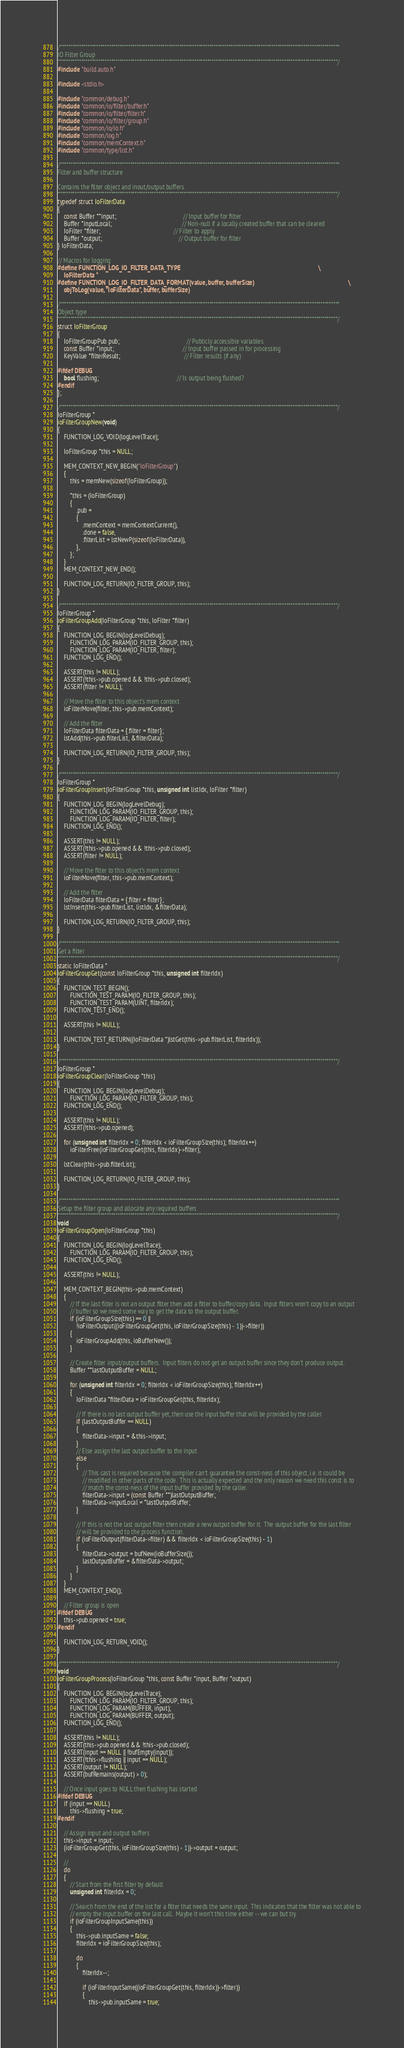Convert code to text. <code><loc_0><loc_0><loc_500><loc_500><_C_>/***********************************************************************************************************************************
IO Filter Group
***********************************************************************************************************************************/
#include "build.auto.h"

#include <stdio.h>

#include "common/debug.h"
#include "common/io/filter/buffer.h"
#include "common/io/filter/filter.h"
#include "common/io/filter/group.h"
#include "common/io/io.h"
#include "common/log.h"
#include "common/memContext.h"
#include "common/type/list.h"

/***********************************************************************************************************************************
Filter and buffer structure

Contains the filter object and inout/output buffers.
***********************************************************************************************************************************/
typedef struct IoFilterData
{
    const Buffer **input;                                           // Input buffer for filter
    Buffer *inputLocal;                                             // Non-null if a locally created buffer that can be cleared
    IoFilter *filter;                                               // Filter to apply
    Buffer *output;                                                 // Output buffer for filter
} IoFilterData;

// Macros for logging
#define FUNCTION_LOG_IO_FILTER_DATA_TYPE                                                                                           \
    IoFilterData *
#define FUNCTION_LOG_IO_FILTER_DATA_FORMAT(value, buffer, bufferSize)                                                              \
    objToLog(value, "IoFilterData", buffer, bufferSize)

/***********************************************************************************************************************************
Object type
***********************************************************************************************************************************/
struct IoFilterGroup
{
    IoFilterGroupPub pub;                                           // Publicly accessible variables
    const Buffer *input;                                            // Input buffer passed in for processing
    KeyValue *filterResult;                                         // Filter results (if any)

#ifdef DEBUG
    bool flushing;                                                  // Is output being flushed?
#endif
};

/**********************************************************************************************************************************/
IoFilterGroup *
ioFilterGroupNew(void)
{
    FUNCTION_LOG_VOID(logLevelTrace);

    IoFilterGroup *this = NULL;

    MEM_CONTEXT_NEW_BEGIN("IoFilterGroup")
    {
        this = memNew(sizeof(IoFilterGroup));

        *this = (IoFilterGroup)
        {
            .pub =
            {
                .memContext = memContextCurrent(),
                .done = false,
                .filterList = lstNewP(sizeof(IoFilterData)),
            },
        };
    }
    MEM_CONTEXT_NEW_END();

    FUNCTION_LOG_RETURN(IO_FILTER_GROUP, this);
}

/**********************************************************************************************************************************/
IoFilterGroup *
ioFilterGroupAdd(IoFilterGroup *this, IoFilter *filter)
{
    FUNCTION_LOG_BEGIN(logLevelDebug);
        FUNCTION_LOG_PARAM(IO_FILTER_GROUP, this);
        FUNCTION_LOG_PARAM(IO_FILTER, filter);
    FUNCTION_LOG_END();

    ASSERT(this != NULL);
    ASSERT(!this->pub.opened && !this->pub.closed);
    ASSERT(filter != NULL);

    // Move the filter to this object's mem context
    ioFilterMove(filter, this->pub.memContext);

    // Add the filter
    IoFilterData filterData = {.filter = filter};
    lstAdd(this->pub.filterList, &filterData);

    FUNCTION_LOG_RETURN(IO_FILTER_GROUP, this);
}

/**********************************************************************************************************************************/
IoFilterGroup *
ioFilterGroupInsert(IoFilterGroup *this, unsigned int listIdx, IoFilter *filter)
{
    FUNCTION_LOG_BEGIN(logLevelDebug);
        FUNCTION_LOG_PARAM(IO_FILTER_GROUP, this);
        FUNCTION_LOG_PARAM(IO_FILTER, filter);
    FUNCTION_LOG_END();

    ASSERT(this != NULL);
    ASSERT(!this->pub.opened && !this->pub.closed);
    ASSERT(filter != NULL);

    // Move the filter to this object's mem context
    ioFilterMove(filter, this->pub.memContext);

    // Add the filter
    IoFilterData filterData = {.filter = filter};
    lstInsert(this->pub.filterList, listIdx, &filterData);

    FUNCTION_LOG_RETURN(IO_FILTER_GROUP, this);
}

/***********************************************************************************************************************************
Get a filter
***********************************************************************************************************************************/
static IoFilterData *
ioFilterGroupGet(const IoFilterGroup *this, unsigned int filterIdx)
{
    FUNCTION_TEST_BEGIN();
        FUNCTION_TEST_PARAM(IO_FILTER_GROUP, this);
        FUNCTION_TEST_PARAM(UINT, filterIdx);
    FUNCTION_TEST_END();

    ASSERT(this != NULL);

    FUNCTION_TEST_RETURN((IoFilterData *)lstGet(this->pub.filterList, filterIdx));
}

/**********************************************************************************************************************************/
IoFilterGroup *
ioFilterGroupClear(IoFilterGroup *this)
{
    FUNCTION_LOG_BEGIN(logLevelDebug);
        FUNCTION_LOG_PARAM(IO_FILTER_GROUP, this);
    FUNCTION_LOG_END();

    ASSERT(this != NULL);
    ASSERT(!this->pub.opened);

    for (unsigned int filterIdx = 0; filterIdx < ioFilterGroupSize(this); filterIdx++)
        ioFilterFree(ioFilterGroupGet(this, filterIdx)->filter);

    lstClear(this->pub.filterList);

    FUNCTION_LOG_RETURN(IO_FILTER_GROUP, this);
}

/***********************************************************************************************************************************
Setup the filter group and allocate any required buffers
***********************************************************************************************************************************/
void
ioFilterGroupOpen(IoFilterGroup *this)
{
    FUNCTION_LOG_BEGIN(logLevelTrace);
        FUNCTION_LOG_PARAM(IO_FILTER_GROUP, this);
    FUNCTION_LOG_END();

    ASSERT(this != NULL);

    MEM_CONTEXT_BEGIN(this->pub.memContext)
    {
        // If the last filter is not an output filter then add a filter to buffer/copy data.  Input filters won't copy to an output
        // buffer so we need some way to get the data to the output buffer.
        if (ioFilterGroupSize(this) == 0 ||
            !ioFilterOutput((ioFilterGroupGet(this, ioFilterGroupSize(this) - 1))->filter))
        {
            ioFilterGroupAdd(this, ioBufferNew());
        }

        // Create filter input/output buffers.  Input filters do not get an output buffer since they don't produce output.
        Buffer **lastOutputBuffer = NULL;

        for (unsigned int filterIdx = 0; filterIdx < ioFilterGroupSize(this); filterIdx++)
        {
            IoFilterData *filterData = ioFilterGroupGet(this, filterIdx);

            // If there is no last output buffer yet, then use the input buffer that will be provided by the caller
            if (lastOutputBuffer == NULL)
            {
                filterData->input = &this->input;
            }
            // Else assign the last output buffer to the input
            else
            {
                // This cast is required because the compiler can't guarantee the const-ness of this object, i.e. it could be
                // modified in other parts of the code.  This is actually expected and the only reason we need this const is to
                // match the const-ness of the input buffer provided by the caller.
                filterData->input = (const Buffer **)lastOutputBuffer;
                filterData->inputLocal = *lastOutputBuffer;
            }

            // If this is not the last output filter then create a new output buffer for it.  The output buffer for the last filter
            // will be provided to the process function.
            if (ioFilterOutput(filterData->filter) && filterIdx < ioFilterGroupSize(this) - 1)
            {
                filterData->output = bufNew(ioBufferSize());
                lastOutputBuffer = &filterData->output;
            }
        }
    }
    MEM_CONTEXT_END();

    // Filter group is open
#ifdef DEBUG
    this->pub.opened = true;
#endif

    FUNCTION_LOG_RETURN_VOID();
}

/**********************************************************************************************************************************/
void
ioFilterGroupProcess(IoFilterGroup *this, const Buffer *input, Buffer *output)
{
    FUNCTION_LOG_BEGIN(logLevelTrace);
        FUNCTION_LOG_PARAM(IO_FILTER_GROUP, this);
        FUNCTION_LOG_PARAM(BUFFER, input);
        FUNCTION_LOG_PARAM(BUFFER, output);
    FUNCTION_LOG_END();

    ASSERT(this != NULL);
    ASSERT(this->pub.opened && !this->pub.closed);
    ASSERT(input == NULL || !bufEmpty(input));
    ASSERT(!this->flushing || input == NULL);
    ASSERT(output != NULL);
    ASSERT(bufRemains(output) > 0);

    // Once input goes to NULL then flushing has started
#ifdef DEBUG
    if (input == NULL)
        this->flushing = true;
#endif

    // Assign input and output buffers
    this->input = input;
    (ioFilterGroupGet(this, ioFilterGroupSize(this) - 1))->output = output;

    //
    do
    {
        // Start from the first filter by default
        unsigned int filterIdx = 0;

        // Search from the end of the list for a filter that needs the same input.  This indicates that the filter was not able to
        // empty the input buffer on the last call.  Maybe it won't this time either -- we can but try.
        if (ioFilterGroupInputSame(this))
        {
            this->pub.inputSame = false;
            filterIdx = ioFilterGroupSize(this);

            do
            {
                filterIdx--;

                if (ioFilterInputSame((ioFilterGroupGet(this, filterIdx))->filter))
                {
                    this->pub.inputSame = true;</code> 